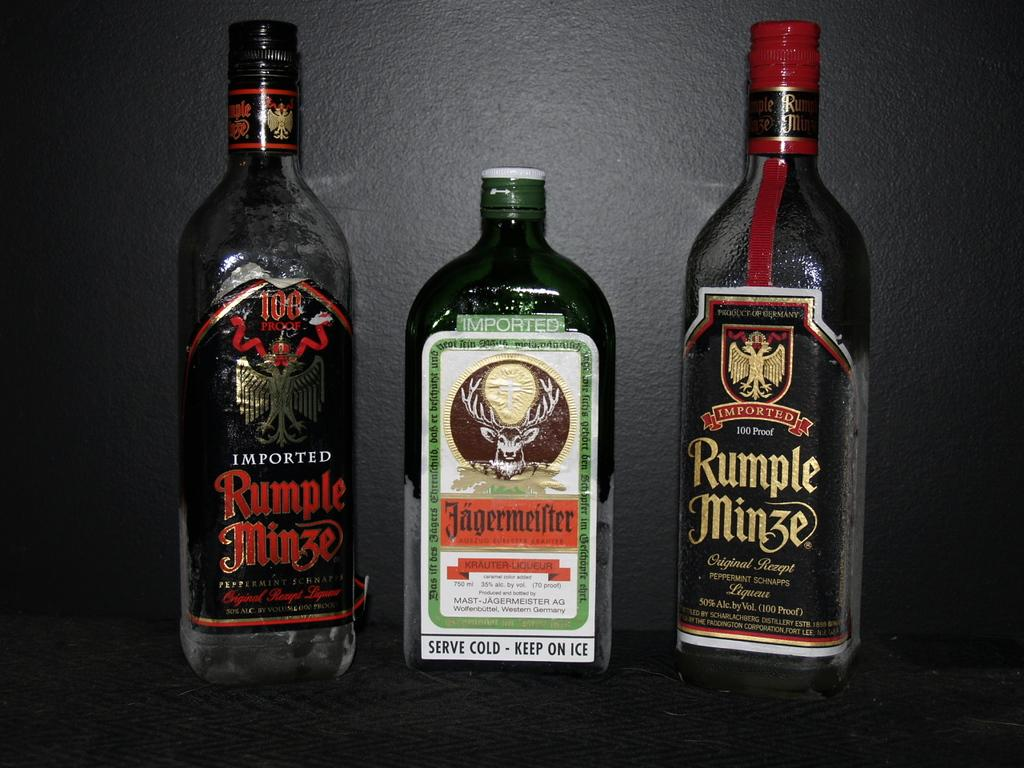What is the setting of the image? The image is of the inside of a location. What objects are in the foreground of the image? There are three glass bottles in the foreground. What is inside the bottles? The bottles contain drinks. Where are the bottles placed? The bottles are placed on a surface. What can be seen in the background of the image? There is a wall visible in the background. What type of cherry is being used as a pen by the writer in the image? There is no writer or cherry present in the image; it features three glass bottles containing drinks on a surface. 